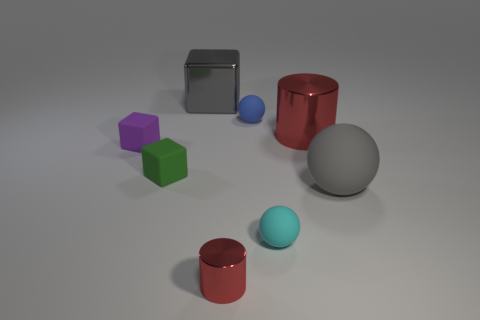Subtract all big spheres. How many spheres are left? 2 Subtract 2 cubes. How many cubes are left? 1 Add 1 green cubes. How many objects exist? 9 Subtract all gray spheres. How many spheres are left? 2 Subtract all spheres. How many objects are left? 5 Add 3 tiny cyan rubber spheres. How many tiny cyan rubber spheres are left? 4 Add 5 rubber objects. How many rubber objects exist? 10 Subtract 0 red spheres. How many objects are left? 8 Subtract all green blocks. Subtract all red spheres. How many blocks are left? 2 Subtract all gray cubes. How many yellow cylinders are left? 0 